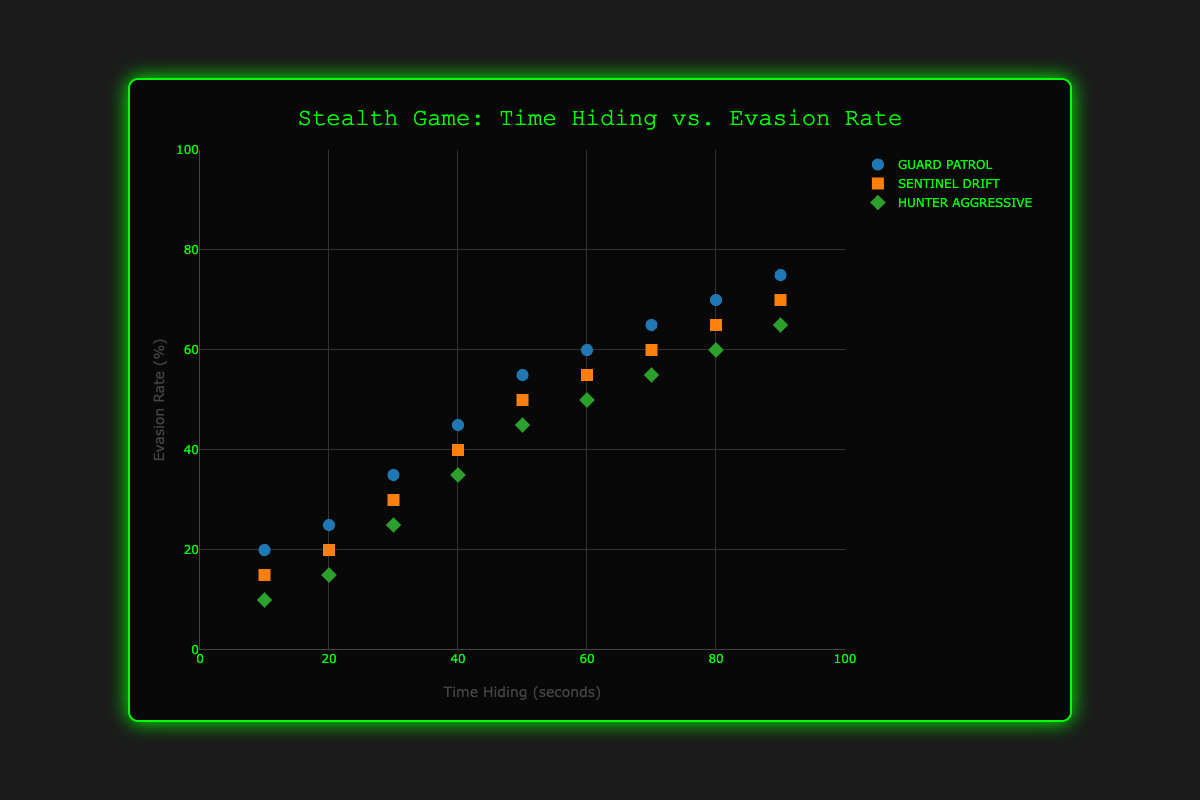What is the title of the figure? The title is usually displayed prominently at the top of the figure.
Answer: Stealth Game: Time Hiding vs. Evasion Rate Which color are the ticks and the gridlines of the axes? The ticks and gridlines are colored to provide contrast against the plot background.
Answer: Green and dark gray respectively How many data points are plotted for each enemy AI behavior? Count the number of markers for each of the three behaviors.
Answer: 9 What is the evasion rate for 'guard patrol' when the time hiding is 50 seconds? Find the data point where the x-coordinate is 50 for 'guard patrol' and read the y-coordinate value.
Answer: 55% Which enemy AI behavior has the lowest overall evasion rates? Compare the y-values (evasion rates) of all three AI behaviors.
Answer: Hunter Aggressive How does the evasion rate change for 'sentinel drift' as time hiding increases from 20 to 60 seconds? Check the evasion rate values for 'sentinel drift' at time 20 seconds and 60 seconds and compute the change.
Answer: It increases from 20% to 55% Which AI behavior shows the highest evasion rate for a time hiding of 80 seconds? Compare the data points at 80 seconds for all AI behaviors and identify the highest y-value.
Answer: Guard Patrol What is the average evasion rate for 'hunter aggressive' based on the data points provided? Sum the evasion rates of 'hunter aggressive' and divide by the number of data points.
Answer: 40% Which AI behavior type appears to benefit the most from increased hiding time? Determine which AI behavior shows the steepest upward trend in evasion rate as time hiding increases.
Answer: Guard Patrol At 30 seconds of time hiding, how does the evasion rate of 'sentinel drift' compare to that of 'hunter aggressive'? Find the evasion rates at 30 seconds for both and compare.
Answer: 5% higher 